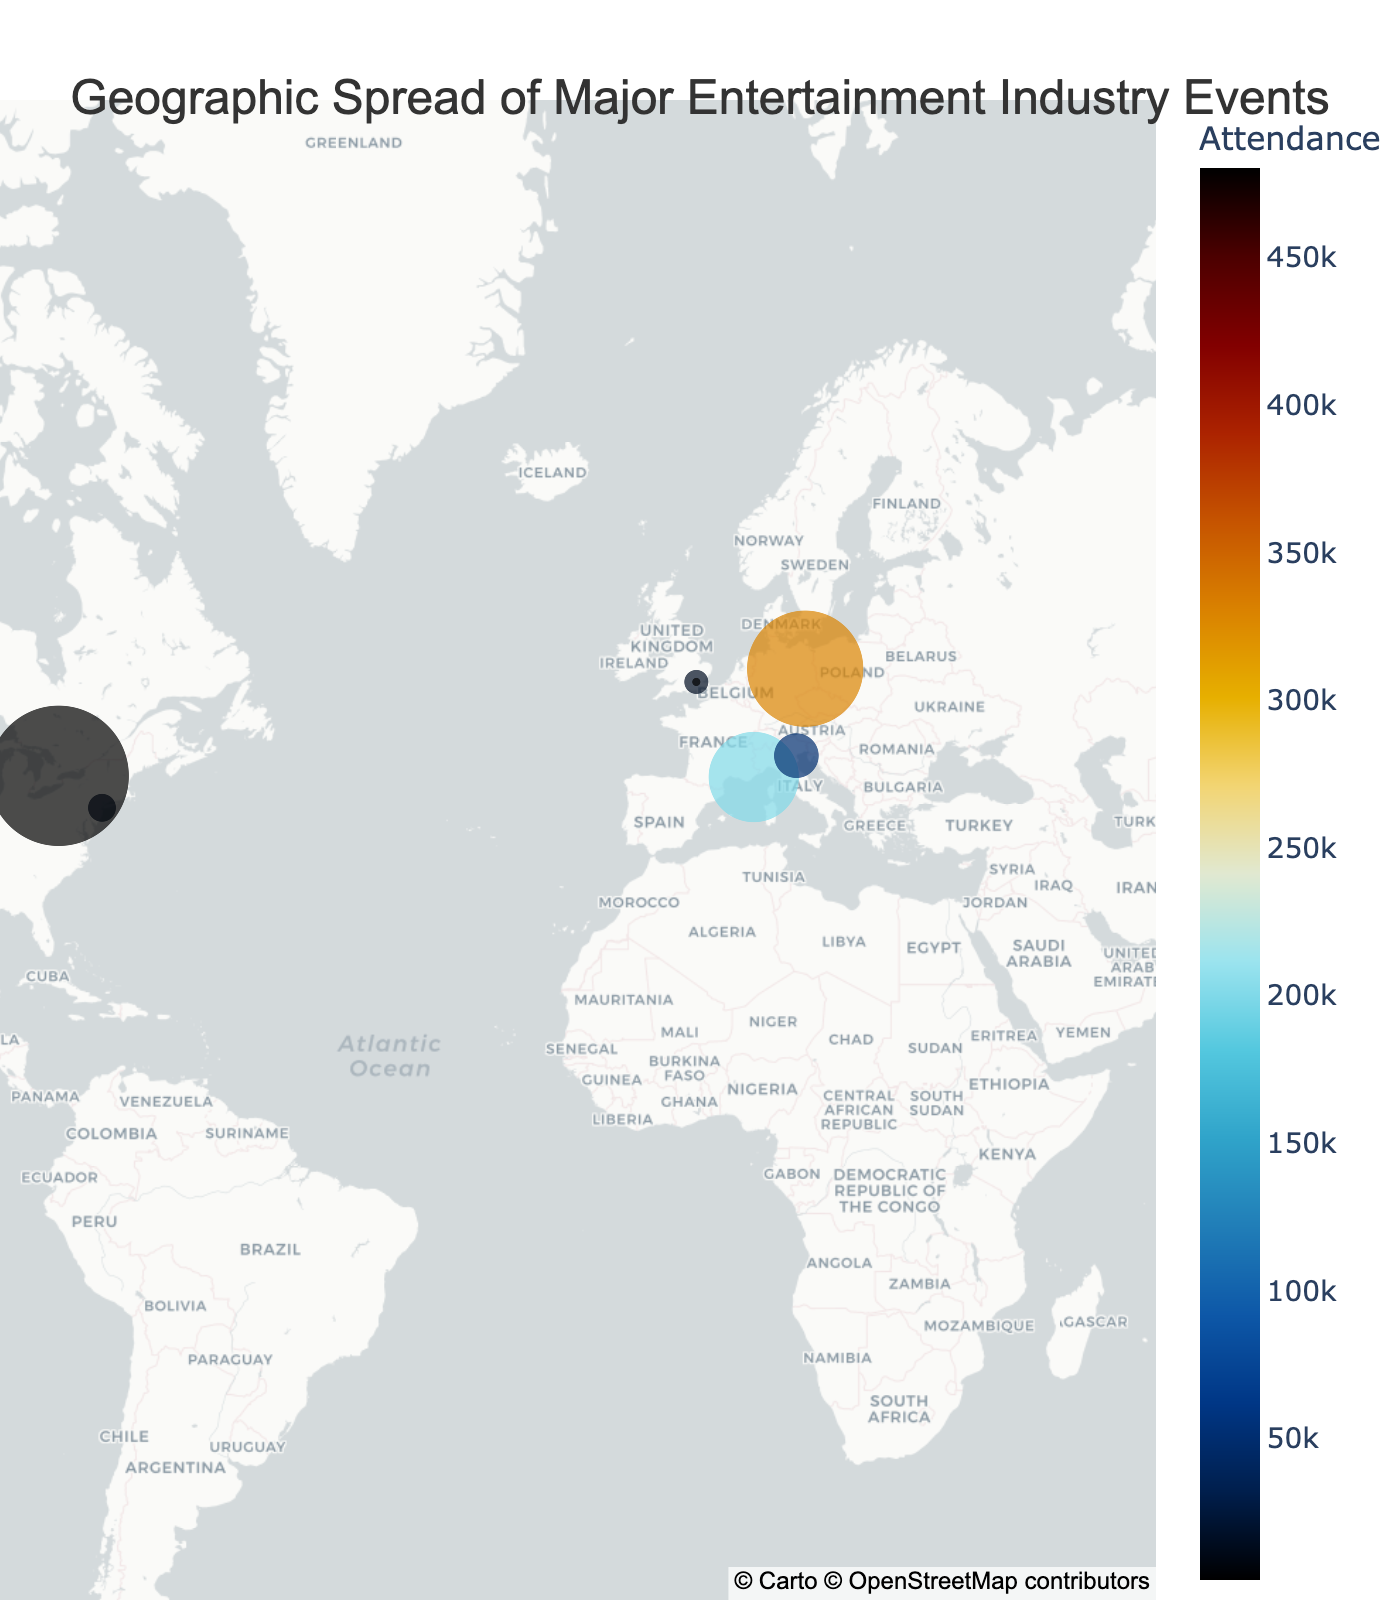How many major entertainment events are represented on the plot? Count the number of data points visible on the map, which corresponds to the number of events.
Answer: 12 Which event has the highest attendance according to the plot? Identify the event with the largest size bubble and look at the hover information or color scale to find the attendance.
Answer: Toronto International Film Festival Where is the Primetime Emmy Awards held according to the plot? Hover over the point representing the Primetime Emmy Awards to see the associated city in the hover data.
Answer: Los Angeles, USA What is the average attendance of all events according to the plot? Sum the attendance values of all events and divide by the number of events: (18000 + 200000 + 15000 + 70000 + 50000 + 20000 + 330000 + 10000 + 480000 + 122000 + 7000 + 2000) / 12 = 106 ,
Answer: 106,750 Which city hosts the most events according to the plot? Count the number of events per city by examining the hover data of each point and summarize.
Answer: Los Angeles How does the attendance of the Berlin International Film Festival compare to the MTV Video Music Awards? Find both events on the map, using the size or hover data, then compare the attendance values: 330,000 vs 20,000.
Answer: Berlin International Film Festival has a higher attendance Are there more events in Europe or North America according to the plot? Count the events in Europe (Cannes, London, Venice, Berlin) and North America (Los Angeles, New York City, Park City, Toronto) using their locations on the map.
Answer: Europe: 4, North America: 5 What is the range of attendance values among the events on the plot? Identify the minimum and maximum attendance values from the hover data and subtract the smallest from the largest: 2,000 (BAFTA Awards) to 480,000 (Toronto International Film Festival).
Answer: 478,000 Which event is held in the southernmost location according to the plot? Identify the event with the lowest latitude value and confirm using the hover data.
Answer: Australian Recording Industry Association Music Awards in Sydney What is the most common continent for hosting these events according to the plot? Determine the continent based on the city and country information for each event, and count the occurrences to find the most frequent.
Answer: North America 